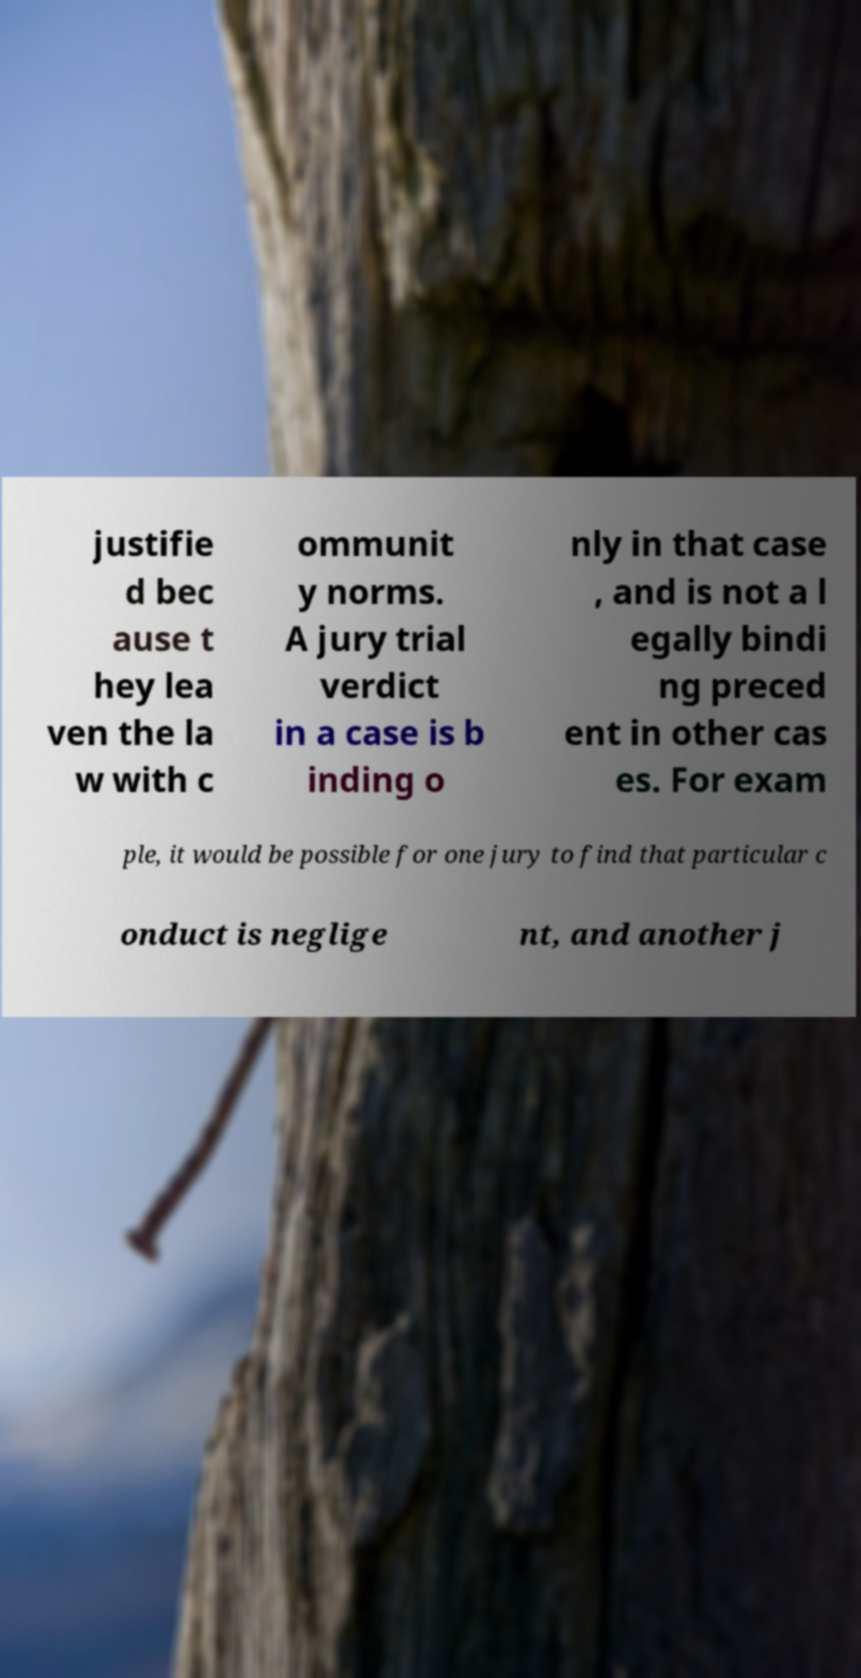There's text embedded in this image that I need extracted. Can you transcribe it verbatim? justifie d bec ause t hey lea ven the la w with c ommunit y norms. A jury trial verdict in a case is b inding o nly in that case , and is not a l egally bindi ng preced ent in other cas es. For exam ple, it would be possible for one jury to find that particular c onduct is neglige nt, and another j 